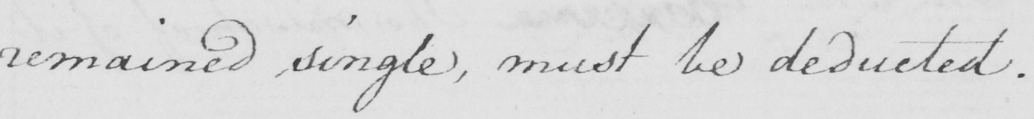What does this handwritten line say? remained single , must be deducted . 